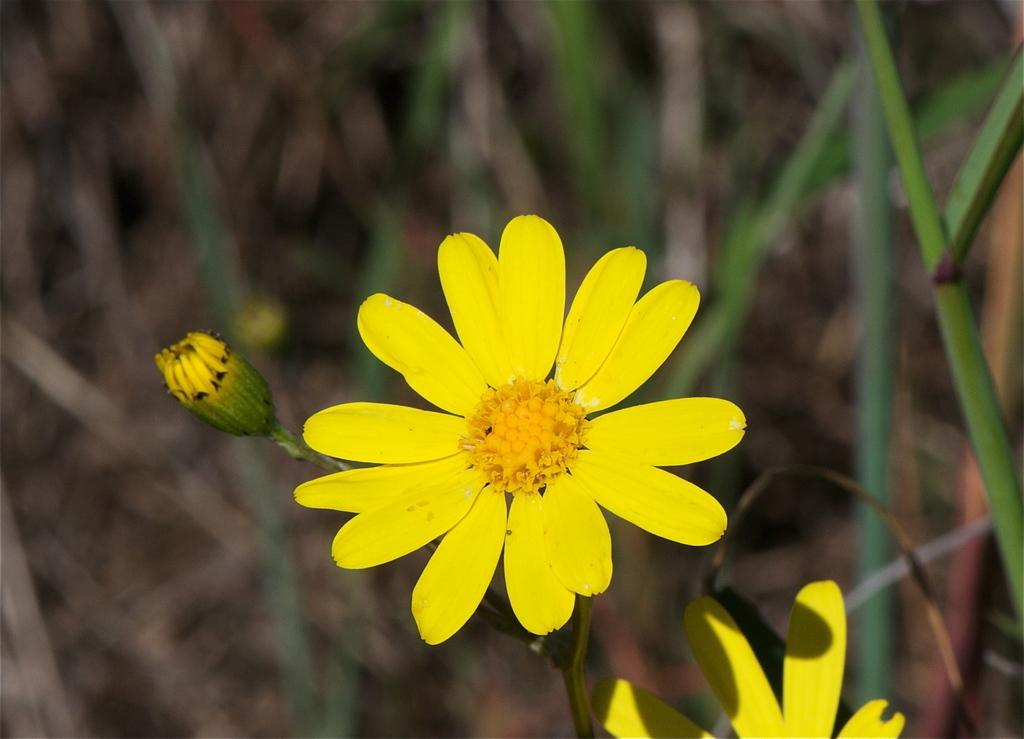What type of flowers can be seen in the image? There are yellow color flowers in the image. Can you describe the background of the image? The background of the image is blurred. What type of snow can be seen on the finger in the image? There is no snow or finger present in the image; it only features yellow color flowers with a blurred background. 